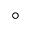Convert formula to latex. <formula><loc_0><loc_0><loc_500><loc_500>^ { \circ }</formula> 